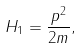Convert formula to latex. <formula><loc_0><loc_0><loc_500><loc_500>H _ { 1 } = \frac { p ^ { 2 } } { 2 m } ,</formula> 